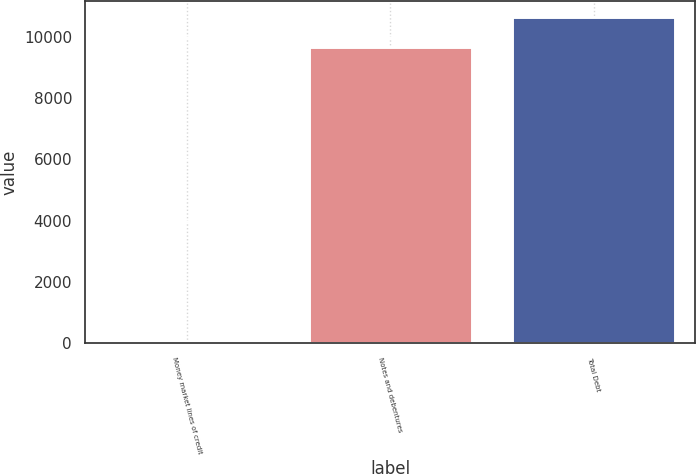<chart> <loc_0><loc_0><loc_500><loc_500><bar_chart><fcel>Money market lines of credit<fcel>Notes and debentures<fcel>Total Debt<nl><fcel>53<fcel>9672<fcel>10639.2<nl></chart> 